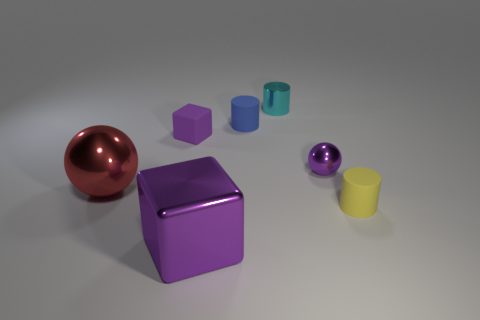How many things are cyan metal cylinders or tiny matte objects in front of the red thing?
Ensure brevity in your answer.  2. The rubber object that is the same color as the metal block is what shape?
Give a very brief answer. Cube. How many purple metallic spheres have the same size as the yellow cylinder?
Your answer should be compact. 1. What number of brown objects are metal cubes or large shiny things?
Ensure brevity in your answer.  0. There is a purple shiny object behind the tiny rubber cylinder right of the tiny cyan object; what is its shape?
Make the answer very short. Sphere. There is a yellow thing that is the same size as the purple rubber thing; what shape is it?
Offer a terse response. Cylinder. Is there a sphere of the same color as the matte block?
Your answer should be very brief. Yes. Are there an equal number of purple rubber objects that are behind the tiny metal sphere and big shiny objects behind the small yellow matte cylinder?
Offer a very short reply. Yes. Is the shape of the small cyan object the same as the purple object that is in front of the tiny yellow cylinder?
Provide a short and direct response. No. What number of other objects are the same material as the red thing?
Ensure brevity in your answer.  3. 